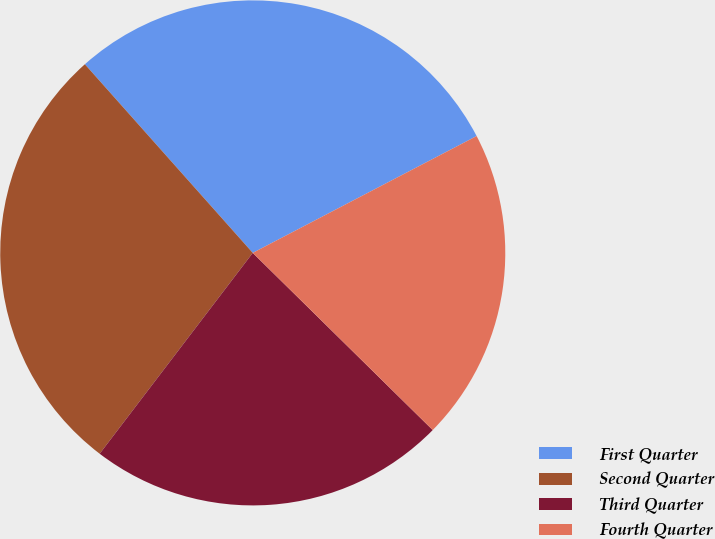<chart> <loc_0><loc_0><loc_500><loc_500><pie_chart><fcel>First Quarter<fcel>Second Quarter<fcel>Third Quarter<fcel>Fourth Quarter<nl><fcel>28.92%<fcel>28.06%<fcel>22.99%<fcel>20.03%<nl></chart> 